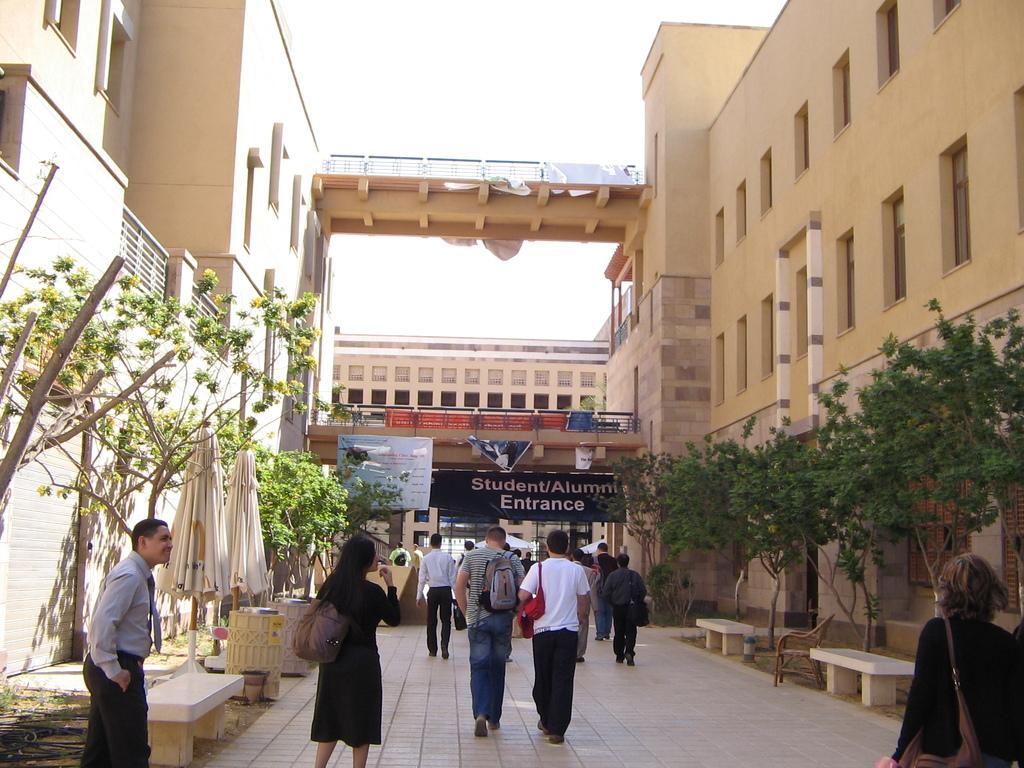In one or two sentences, can you explain what this image depicts? In this image we can see many people. On the sides there are many buildings with windows and railings. Also there are trees. And there are umbrellas and benches. In the back there are bridges with railings. Also there are banners. And there are buildings. Also there is sky. 